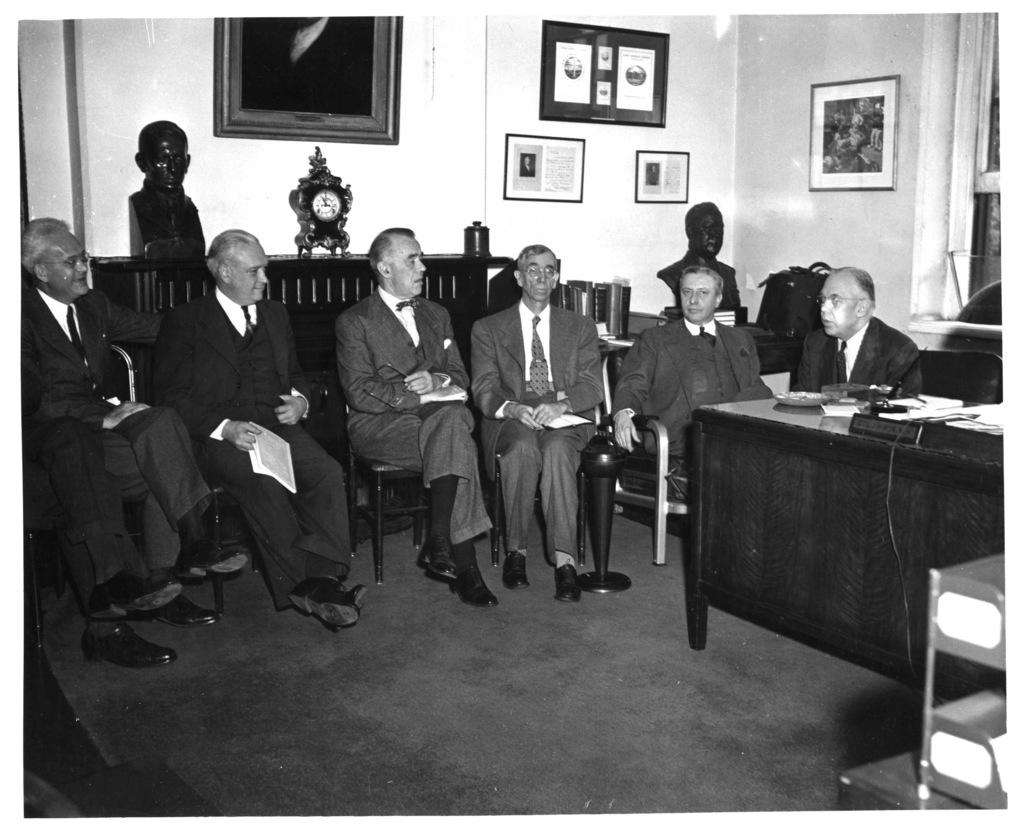What are the men in the image doing? The men in the image are sitting on chairs. What can be seen on the walls in the background of the image? There are frames on the walls in the background of the image. What time-telling device is visible in the background of the image? There is a clock visible in the background of the image. What type of writer is sitting in the chair in the image? There is no writer present in the image; it only shows men sitting on chairs. What adjustments are being made to the clock in the image? There is no adjustment being made to the clock in the image; it is simply visible in the background. 